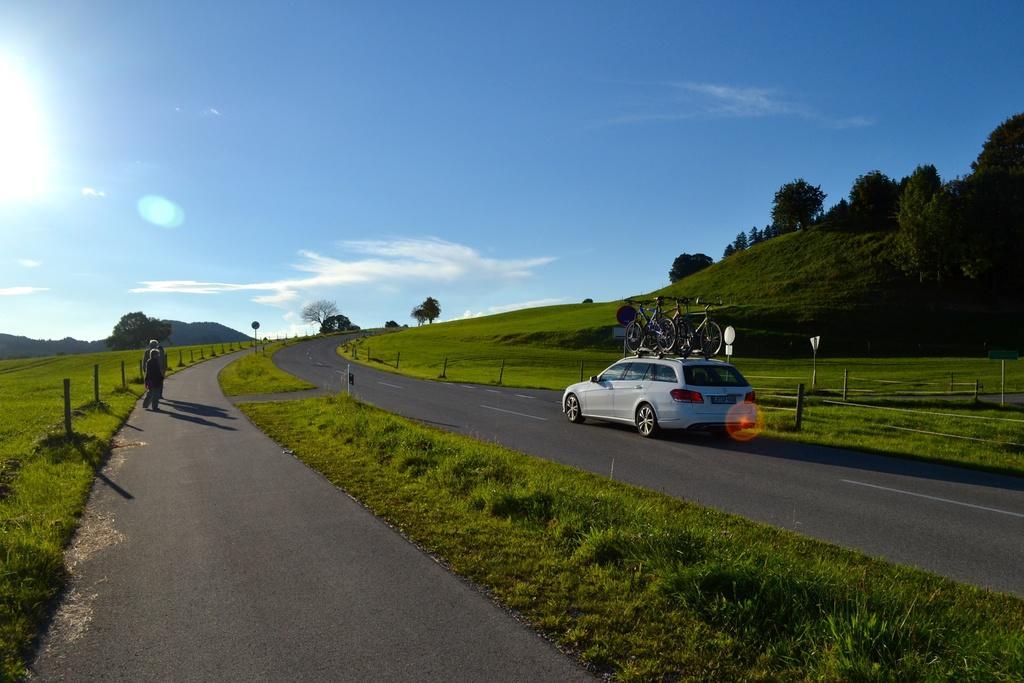In one or two sentences, can you explain what this image depicts? In this picture, on the left side some people are there. And this is the roadway. And this is car which carrying some bicycle. 